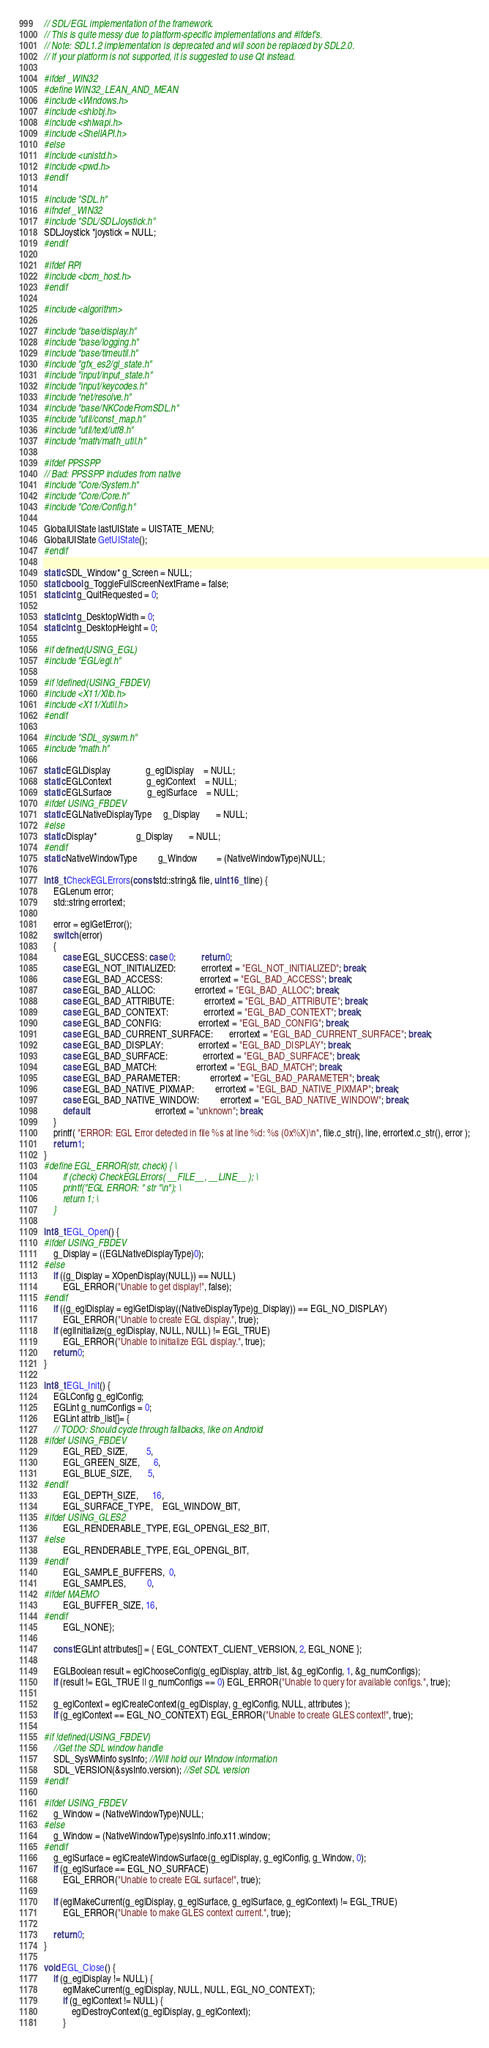Convert code to text. <code><loc_0><loc_0><loc_500><loc_500><_C++_>// SDL/EGL implementation of the framework.
// This is quite messy due to platform-specific implementations and #ifdef's.
// Note: SDL1.2 implementation is deprecated and will soon be replaced by SDL2.0.
// If your platform is not supported, it is suggested to use Qt instead.

#ifdef _WIN32
#define WIN32_LEAN_AND_MEAN
#include <Windows.h>
#include <shlobj.h>
#include <shlwapi.h>
#include <ShellAPI.h>
#else
#include <unistd.h>
#include <pwd.h>
#endif

#include "SDL.h"
#ifndef _WIN32
#include "SDL/SDLJoystick.h"
SDLJoystick *joystick = NULL;
#endif

#ifdef RPI
#include <bcm_host.h>
#endif

#include <algorithm>

#include "base/display.h"
#include "base/logging.h"
#include "base/timeutil.h"
#include "gfx_es2/gl_state.h"
#include "input/input_state.h"
#include "input/keycodes.h"
#include "net/resolve.h"
#include "base/NKCodeFromSDL.h"
#include "util/const_map.h"
#include "util/text/utf8.h"
#include "math/math_util.h"

#ifdef PPSSPP
// Bad: PPSSPP includes from native
#include "Core/System.h"
#include "Core/Core.h"
#include "Core/Config.h"

GlobalUIState lastUIState = UISTATE_MENU;
GlobalUIState GetUIState();
#endif

static SDL_Window* g_Screen = NULL;
static bool g_ToggleFullScreenNextFrame = false;
static int g_QuitRequested = 0;

static int g_DesktopWidth = 0;
static int g_DesktopHeight = 0;

#if defined(USING_EGL)
#include "EGL/egl.h"

#if !defined(USING_FBDEV)
#include <X11/Xlib.h>
#include <X11/Xutil.h>
#endif

#include "SDL_syswm.h"
#include "math.h"

static EGLDisplay               g_eglDisplay    = NULL;
static EGLContext               g_eglContext    = NULL;
static EGLSurface               g_eglSurface    = NULL;
#ifdef USING_FBDEV
static EGLNativeDisplayType     g_Display       = NULL;
#else
static Display*                 g_Display       = NULL;
#endif
static NativeWindowType         g_Window        = (NativeWindowType)NULL;

int8_t CheckEGLErrors(const std::string& file, uint16_t line) {
	EGLenum error;
	std::string errortext;

	error = eglGetError();
	switch (error)
	{
		case EGL_SUCCESS: case 0:           return 0;
		case EGL_NOT_INITIALIZED:           errortext = "EGL_NOT_INITIALIZED"; break;
		case EGL_BAD_ACCESS:                errortext = "EGL_BAD_ACCESS"; break;
		case EGL_BAD_ALLOC:                 errortext = "EGL_BAD_ALLOC"; break;
		case EGL_BAD_ATTRIBUTE:             errortext = "EGL_BAD_ATTRIBUTE"; break;
		case EGL_BAD_CONTEXT:               errortext = "EGL_BAD_CONTEXT"; break;
		case EGL_BAD_CONFIG:                errortext = "EGL_BAD_CONFIG"; break;
		case EGL_BAD_CURRENT_SURFACE:       errortext = "EGL_BAD_CURRENT_SURFACE"; break;
		case EGL_BAD_DISPLAY:               errortext = "EGL_BAD_DISPLAY"; break;
		case EGL_BAD_SURFACE:               errortext = "EGL_BAD_SURFACE"; break;
		case EGL_BAD_MATCH:                 errortext = "EGL_BAD_MATCH"; break;
		case EGL_BAD_PARAMETER:             errortext = "EGL_BAD_PARAMETER"; break;
		case EGL_BAD_NATIVE_PIXMAP:         errortext = "EGL_BAD_NATIVE_PIXMAP"; break;
		case EGL_BAD_NATIVE_WINDOW:         errortext = "EGL_BAD_NATIVE_WINDOW"; break;
		default:                            errortext = "unknown"; break;
	}
	printf( "ERROR: EGL Error detected in file %s at line %d: %s (0x%X)\n", file.c_str(), line, errortext.c_str(), error );
	return 1;
}
#define EGL_ERROR(str, check) { \
		if (check) CheckEGLErrors( __FILE__, __LINE__ ); \
		printf("EGL ERROR: " str "\n"); \
		return 1; \
	}

int8_t EGL_Open() {
#ifdef USING_FBDEV
	g_Display = ((EGLNativeDisplayType)0);
#else
	if ((g_Display = XOpenDisplay(NULL)) == NULL)
		EGL_ERROR("Unable to get display!", false);
#endif
	if ((g_eglDisplay = eglGetDisplay((NativeDisplayType)g_Display)) == EGL_NO_DISPLAY)
		EGL_ERROR("Unable to create EGL display.", true);
	if (eglInitialize(g_eglDisplay, NULL, NULL) != EGL_TRUE)
		EGL_ERROR("Unable to initialize EGL display.", true);
	return 0;
}

int8_t EGL_Init() {
	EGLConfig g_eglConfig;
	EGLint g_numConfigs = 0;
	EGLint attrib_list[]= {
	// TODO: Should cycle through fallbacks, like on Android
#ifdef USING_FBDEV
		EGL_RED_SIZE,        5,
		EGL_GREEN_SIZE,      6,
		EGL_BLUE_SIZE,       5,
#endif
		EGL_DEPTH_SIZE,      16,
		EGL_SURFACE_TYPE,    EGL_WINDOW_BIT,
#ifdef USING_GLES2
		EGL_RENDERABLE_TYPE, EGL_OPENGL_ES2_BIT,
#else
		EGL_RENDERABLE_TYPE, EGL_OPENGL_BIT,
#endif
		EGL_SAMPLE_BUFFERS,  0,
		EGL_SAMPLES,         0,
#ifdef MAEMO
		EGL_BUFFER_SIZE, 16,
#endif
		EGL_NONE};

	const EGLint attributes[] = { EGL_CONTEXT_CLIENT_VERSION, 2, EGL_NONE };

	EGLBoolean result = eglChooseConfig(g_eglDisplay, attrib_list, &g_eglConfig, 1, &g_numConfigs);
	if (result != EGL_TRUE || g_numConfigs == 0) EGL_ERROR("Unable to query for available configs.", true);

	g_eglContext = eglCreateContext(g_eglDisplay, g_eglConfig, NULL, attributes );
	if (g_eglContext == EGL_NO_CONTEXT) EGL_ERROR("Unable to create GLES context!", true);

#if !defined(USING_FBDEV)
	//Get the SDL window handle
	SDL_SysWMinfo sysInfo; //Will hold our Window information
	SDL_VERSION(&sysInfo.version); //Set SDL version
#endif

#ifdef USING_FBDEV
	g_Window = (NativeWindowType)NULL;
#else
	g_Window = (NativeWindowType)sysInfo.info.x11.window;
#endif
	g_eglSurface = eglCreateWindowSurface(g_eglDisplay, g_eglConfig, g_Window, 0);
	if (g_eglSurface == EGL_NO_SURFACE)
		EGL_ERROR("Unable to create EGL surface!", true);

	if (eglMakeCurrent(g_eglDisplay, g_eglSurface, g_eglSurface, g_eglContext) != EGL_TRUE)
		EGL_ERROR("Unable to make GLES context current.", true);

	return 0;
}

void EGL_Close() {
	if (g_eglDisplay != NULL) {
		eglMakeCurrent(g_eglDisplay, NULL, NULL, EGL_NO_CONTEXT);
		if (g_eglContext != NULL) {
			eglDestroyContext(g_eglDisplay, g_eglContext);
		}</code> 